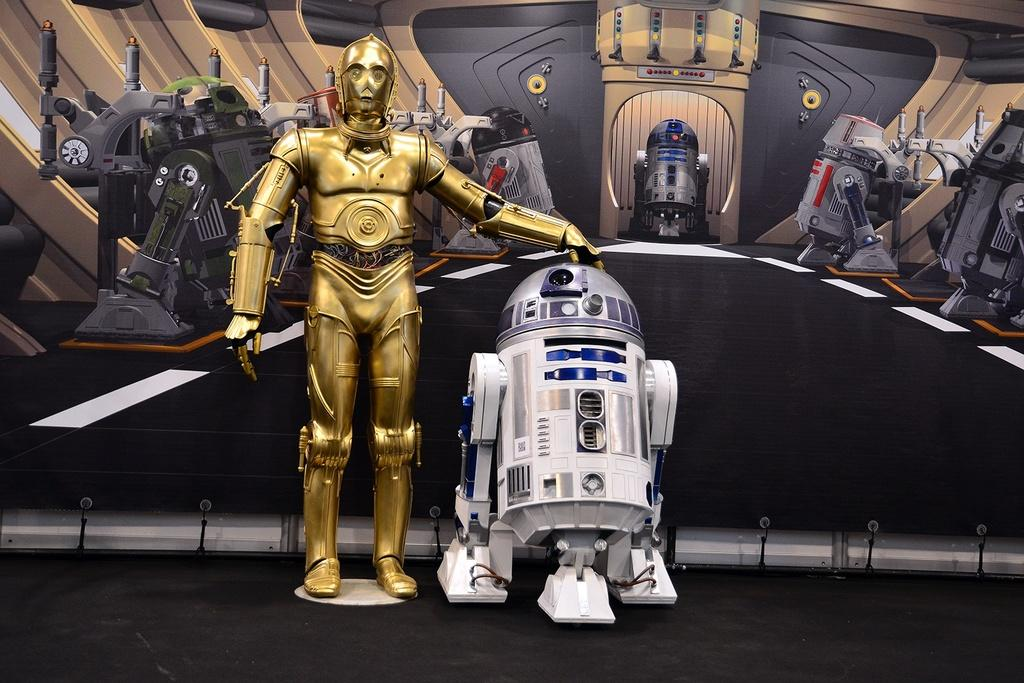What is the main subject of the image? There are robots in the center of the image. What can be seen in the background of the image? There is a board in the background of the image. What part of the image shows the surface on which the robots are standing? The floor is visible at the bottom of the image. What type of screw is used to assemble the robots in the image? There is no information about screws or assembly in the image, as it only shows the robots and their surroundings. 